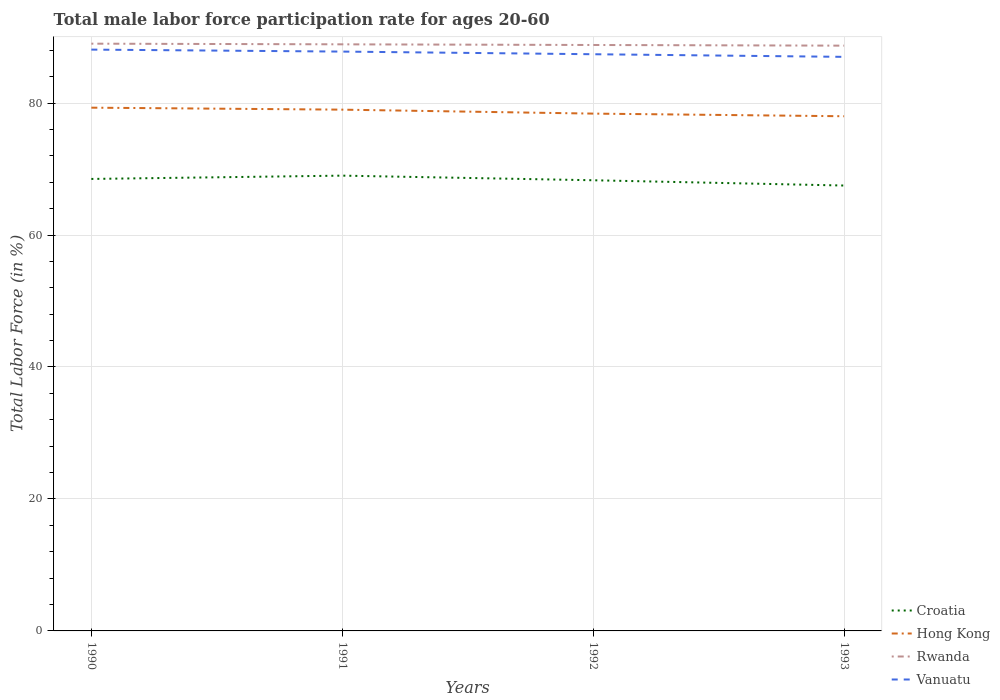How many different coloured lines are there?
Provide a short and direct response. 4. Across all years, what is the maximum male labor force participation rate in Croatia?
Your answer should be compact. 67.5. What is the total male labor force participation rate in Hong Kong in the graph?
Offer a terse response. 0.3. What is the difference between the highest and the second highest male labor force participation rate in Rwanda?
Offer a very short reply. 0.3. What is the difference between the highest and the lowest male labor force participation rate in Rwanda?
Offer a terse response. 2. Is the male labor force participation rate in Vanuatu strictly greater than the male labor force participation rate in Croatia over the years?
Give a very brief answer. No. How many lines are there?
Provide a succinct answer. 4. How many years are there in the graph?
Offer a very short reply. 4. What is the difference between two consecutive major ticks on the Y-axis?
Provide a succinct answer. 20. Are the values on the major ticks of Y-axis written in scientific E-notation?
Offer a very short reply. No. How are the legend labels stacked?
Your response must be concise. Vertical. What is the title of the graph?
Offer a terse response. Total male labor force participation rate for ages 20-60. What is the Total Labor Force (in %) of Croatia in 1990?
Provide a succinct answer. 68.5. What is the Total Labor Force (in %) of Hong Kong in 1990?
Provide a succinct answer. 79.3. What is the Total Labor Force (in %) of Rwanda in 1990?
Provide a succinct answer. 89. What is the Total Labor Force (in %) of Vanuatu in 1990?
Offer a very short reply. 88.1. What is the Total Labor Force (in %) of Hong Kong in 1991?
Make the answer very short. 79. What is the Total Labor Force (in %) of Rwanda in 1991?
Provide a short and direct response. 88.9. What is the Total Labor Force (in %) of Vanuatu in 1991?
Keep it short and to the point. 87.8. What is the Total Labor Force (in %) of Croatia in 1992?
Your answer should be compact. 68.3. What is the Total Labor Force (in %) of Hong Kong in 1992?
Make the answer very short. 78.4. What is the Total Labor Force (in %) in Rwanda in 1992?
Make the answer very short. 88.8. What is the Total Labor Force (in %) of Vanuatu in 1992?
Offer a very short reply. 87.4. What is the Total Labor Force (in %) of Croatia in 1993?
Offer a terse response. 67.5. What is the Total Labor Force (in %) of Hong Kong in 1993?
Keep it short and to the point. 78. What is the Total Labor Force (in %) in Rwanda in 1993?
Offer a terse response. 88.7. Across all years, what is the maximum Total Labor Force (in %) of Hong Kong?
Offer a very short reply. 79.3. Across all years, what is the maximum Total Labor Force (in %) in Rwanda?
Make the answer very short. 89. Across all years, what is the maximum Total Labor Force (in %) of Vanuatu?
Offer a very short reply. 88.1. Across all years, what is the minimum Total Labor Force (in %) of Croatia?
Ensure brevity in your answer.  67.5. Across all years, what is the minimum Total Labor Force (in %) in Hong Kong?
Keep it short and to the point. 78. Across all years, what is the minimum Total Labor Force (in %) of Rwanda?
Your answer should be compact. 88.7. What is the total Total Labor Force (in %) in Croatia in the graph?
Make the answer very short. 273.3. What is the total Total Labor Force (in %) in Hong Kong in the graph?
Your response must be concise. 314.7. What is the total Total Labor Force (in %) in Rwanda in the graph?
Give a very brief answer. 355.4. What is the total Total Labor Force (in %) in Vanuatu in the graph?
Your response must be concise. 350.3. What is the difference between the Total Labor Force (in %) in Rwanda in 1990 and that in 1991?
Provide a succinct answer. 0.1. What is the difference between the Total Labor Force (in %) in Vanuatu in 1990 and that in 1991?
Make the answer very short. 0.3. What is the difference between the Total Labor Force (in %) in Hong Kong in 1990 and that in 1992?
Your answer should be very brief. 0.9. What is the difference between the Total Labor Force (in %) in Vanuatu in 1990 and that in 1992?
Give a very brief answer. 0.7. What is the difference between the Total Labor Force (in %) of Croatia in 1990 and that in 1993?
Provide a short and direct response. 1. What is the difference between the Total Labor Force (in %) of Hong Kong in 1990 and that in 1993?
Your answer should be compact. 1.3. What is the difference between the Total Labor Force (in %) of Hong Kong in 1991 and that in 1992?
Give a very brief answer. 0.6. What is the difference between the Total Labor Force (in %) of Croatia in 1991 and that in 1993?
Make the answer very short. 1.5. What is the difference between the Total Labor Force (in %) of Hong Kong in 1991 and that in 1993?
Your response must be concise. 1. What is the difference between the Total Labor Force (in %) in Rwanda in 1991 and that in 1993?
Provide a succinct answer. 0.2. What is the difference between the Total Labor Force (in %) of Vanuatu in 1991 and that in 1993?
Keep it short and to the point. 0.8. What is the difference between the Total Labor Force (in %) of Hong Kong in 1992 and that in 1993?
Ensure brevity in your answer.  0.4. What is the difference between the Total Labor Force (in %) in Croatia in 1990 and the Total Labor Force (in %) in Rwanda in 1991?
Ensure brevity in your answer.  -20.4. What is the difference between the Total Labor Force (in %) in Croatia in 1990 and the Total Labor Force (in %) in Vanuatu in 1991?
Ensure brevity in your answer.  -19.3. What is the difference between the Total Labor Force (in %) of Hong Kong in 1990 and the Total Labor Force (in %) of Rwanda in 1991?
Your response must be concise. -9.6. What is the difference between the Total Labor Force (in %) in Hong Kong in 1990 and the Total Labor Force (in %) in Vanuatu in 1991?
Offer a very short reply. -8.5. What is the difference between the Total Labor Force (in %) in Croatia in 1990 and the Total Labor Force (in %) in Hong Kong in 1992?
Your answer should be very brief. -9.9. What is the difference between the Total Labor Force (in %) of Croatia in 1990 and the Total Labor Force (in %) of Rwanda in 1992?
Offer a terse response. -20.3. What is the difference between the Total Labor Force (in %) of Croatia in 1990 and the Total Labor Force (in %) of Vanuatu in 1992?
Make the answer very short. -18.9. What is the difference between the Total Labor Force (in %) in Hong Kong in 1990 and the Total Labor Force (in %) in Vanuatu in 1992?
Provide a succinct answer. -8.1. What is the difference between the Total Labor Force (in %) in Rwanda in 1990 and the Total Labor Force (in %) in Vanuatu in 1992?
Make the answer very short. 1.6. What is the difference between the Total Labor Force (in %) in Croatia in 1990 and the Total Labor Force (in %) in Rwanda in 1993?
Provide a succinct answer. -20.2. What is the difference between the Total Labor Force (in %) in Croatia in 1990 and the Total Labor Force (in %) in Vanuatu in 1993?
Keep it short and to the point. -18.5. What is the difference between the Total Labor Force (in %) in Hong Kong in 1990 and the Total Labor Force (in %) in Vanuatu in 1993?
Your answer should be compact. -7.7. What is the difference between the Total Labor Force (in %) of Croatia in 1991 and the Total Labor Force (in %) of Rwanda in 1992?
Your answer should be very brief. -19.8. What is the difference between the Total Labor Force (in %) of Croatia in 1991 and the Total Labor Force (in %) of Vanuatu in 1992?
Keep it short and to the point. -18.4. What is the difference between the Total Labor Force (in %) of Hong Kong in 1991 and the Total Labor Force (in %) of Vanuatu in 1992?
Ensure brevity in your answer.  -8.4. What is the difference between the Total Labor Force (in %) in Rwanda in 1991 and the Total Labor Force (in %) in Vanuatu in 1992?
Your answer should be compact. 1.5. What is the difference between the Total Labor Force (in %) in Croatia in 1991 and the Total Labor Force (in %) in Rwanda in 1993?
Your answer should be compact. -19.7. What is the difference between the Total Labor Force (in %) in Croatia in 1991 and the Total Labor Force (in %) in Vanuatu in 1993?
Keep it short and to the point. -18. What is the difference between the Total Labor Force (in %) of Hong Kong in 1991 and the Total Labor Force (in %) of Vanuatu in 1993?
Offer a terse response. -8. What is the difference between the Total Labor Force (in %) of Rwanda in 1991 and the Total Labor Force (in %) of Vanuatu in 1993?
Keep it short and to the point. 1.9. What is the difference between the Total Labor Force (in %) in Croatia in 1992 and the Total Labor Force (in %) in Rwanda in 1993?
Offer a very short reply. -20.4. What is the difference between the Total Labor Force (in %) of Croatia in 1992 and the Total Labor Force (in %) of Vanuatu in 1993?
Provide a succinct answer. -18.7. What is the difference between the Total Labor Force (in %) of Hong Kong in 1992 and the Total Labor Force (in %) of Vanuatu in 1993?
Your answer should be very brief. -8.6. What is the average Total Labor Force (in %) of Croatia per year?
Offer a terse response. 68.33. What is the average Total Labor Force (in %) in Hong Kong per year?
Keep it short and to the point. 78.67. What is the average Total Labor Force (in %) of Rwanda per year?
Provide a short and direct response. 88.85. What is the average Total Labor Force (in %) in Vanuatu per year?
Provide a short and direct response. 87.58. In the year 1990, what is the difference between the Total Labor Force (in %) in Croatia and Total Labor Force (in %) in Rwanda?
Ensure brevity in your answer.  -20.5. In the year 1990, what is the difference between the Total Labor Force (in %) in Croatia and Total Labor Force (in %) in Vanuatu?
Offer a terse response. -19.6. In the year 1990, what is the difference between the Total Labor Force (in %) of Hong Kong and Total Labor Force (in %) of Vanuatu?
Offer a terse response. -8.8. In the year 1991, what is the difference between the Total Labor Force (in %) in Croatia and Total Labor Force (in %) in Hong Kong?
Your response must be concise. -10. In the year 1991, what is the difference between the Total Labor Force (in %) of Croatia and Total Labor Force (in %) of Rwanda?
Your answer should be very brief. -19.9. In the year 1991, what is the difference between the Total Labor Force (in %) of Croatia and Total Labor Force (in %) of Vanuatu?
Your answer should be compact. -18.8. In the year 1991, what is the difference between the Total Labor Force (in %) in Hong Kong and Total Labor Force (in %) in Vanuatu?
Your answer should be very brief. -8.8. In the year 1991, what is the difference between the Total Labor Force (in %) of Rwanda and Total Labor Force (in %) of Vanuatu?
Make the answer very short. 1.1. In the year 1992, what is the difference between the Total Labor Force (in %) in Croatia and Total Labor Force (in %) in Hong Kong?
Provide a succinct answer. -10.1. In the year 1992, what is the difference between the Total Labor Force (in %) of Croatia and Total Labor Force (in %) of Rwanda?
Offer a very short reply. -20.5. In the year 1992, what is the difference between the Total Labor Force (in %) of Croatia and Total Labor Force (in %) of Vanuatu?
Your answer should be compact. -19.1. In the year 1992, what is the difference between the Total Labor Force (in %) in Hong Kong and Total Labor Force (in %) in Rwanda?
Your answer should be very brief. -10.4. In the year 1992, what is the difference between the Total Labor Force (in %) in Hong Kong and Total Labor Force (in %) in Vanuatu?
Your answer should be very brief. -9. In the year 1993, what is the difference between the Total Labor Force (in %) in Croatia and Total Labor Force (in %) in Rwanda?
Give a very brief answer. -21.2. In the year 1993, what is the difference between the Total Labor Force (in %) of Croatia and Total Labor Force (in %) of Vanuatu?
Give a very brief answer. -19.5. In the year 1993, what is the difference between the Total Labor Force (in %) in Hong Kong and Total Labor Force (in %) in Rwanda?
Provide a short and direct response. -10.7. In the year 1993, what is the difference between the Total Labor Force (in %) in Hong Kong and Total Labor Force (in %) in Vanuatu?
Provide a succinct answer. -9. In the year 1993, what is the difference between the Total Labor Force (in %) in Rwanda and Total Labor Force (in %) in Vanuatu?
Your response must be concise. 1.7. What is the ratio of the Total Labor Force (in %) of Croatia in 1990 to that in 1991?
Provide a short and direct response. 0.99. What is the ratio of the Total Labor Force (in %) in Vanuatu in 1990 to that in 1991?
Give a very brief answer. 1. What is the ratio of the Total Labor Force (in %) of Hong Kong in 1990 to that in 1992?
Your answer should be compact. 1.01. What is the ratio of the Total Labor Force (in %) in Croatia in 1990 to that in 1993?
Provide a short and direct response. 1.01. What is the ratio of the Total Labor Force (in %) in Hong Kong in 1990 to that in 1993?
Keep it short and to the point. 1.02. What is the ratio of the Total Labor Force (in %) in Vanuatu in 1990 to that in 1993?
Make the answer very short. 1.01. What is the ratio of the Total Labor Force (in %) of Croatia in 1991 to that in 1992?
Give a very brief answer. 1.01. What is the ratio of the Total Labor Force (in %) in Hong Kong in 1991 to that in 1992?
Your response must be concise. 1.01. What is the ratio of the Total Labor Force (in %) of Croatia in 1991 to that in 1993?
Provide a succinct answer. 1.02. What is the ratio of the Total Labor Force (in %) in Hong Kong in 1991 to that in 1993?
Provide a short and direct response. 1.01. What is the ratio of the Total Labor Force (in %) in Vanuatu in 1991 to that in 1993?
Your answer should be compact. 1.01. What is the ratio of the Total Labor Force (in %) in Croatia in 1992 to that in 1993?
Your response must be concise. 1.01. What is the ratio of the Total Labor Force (in %) of Rwanda in 1992 to that in 1993?
Give a very brief answer. 1. What is the difference between the highest and the second highest Total Labor Force (in %) in Vanuatu?
Ensure brevity in your answer.  0.3. 